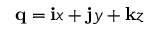Convert formula to latex. <formula><loc_0><loc_0><loc_500><loc_500>q = i x + j y + k z</formula> 